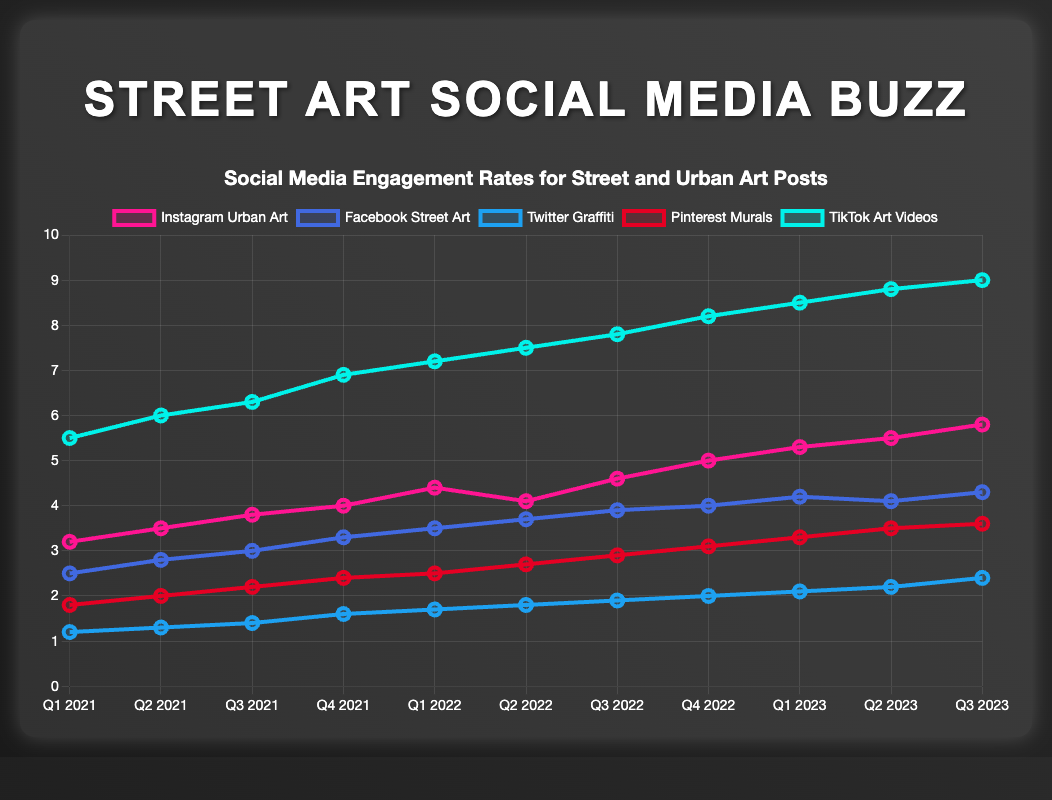Which platform shows the highest engagement rate in Q3 2023? The line chart shows the engagement rates for various platforms. TikTok Art Videos have the highest engagement rate in Q3 2023.
Answer: TikTok Art Videos How much did the engagement rate for Twitter Graffiti increase from Q1 2021 to Q3 2023? In Q1 2021, the engagement rate for Twitter Graffiti was 1.2. By Q3 2023, it increased to 2.4. The increase is 2.4 - 1.2 = 1.2.
Answer: 1.2 Which platform had a declining engagement rate in any quarter over the observed period? Referring to the line chart, Instagram Urban Art shows a decline from Q1 2022 to Q2 2022 going from 4.4 to 4.1.
Answer: Instagram Urban Art What was the average engagement rate for Pinterest Murals over the entire period? Sum the engagement rates for Pinterest Murals over all quarters and then divide by the number of data points:
(1.8 + 2.0 + 2.2 + 2.4 + 2.5 + 2.7 + 2.9 + 3.1 + 3.3 + 3.5 + 3.6) / 11 = 30.0 / 11 ≈ 2.73
Answer: 2.73 In which quarter did Facebook Street Art reach its peak engagement rate? The highest engagement rate for Facebook Street Art is observed at 4.3, which occurs in Q3 2023.
Answer: Q3 2023 What is the sum of engagement rates for Instagram Urban Art and TikTok Art Videos in Q1 2023? The engagement rates for Q1 2023 are: 
- Instagram Urban Art: 5.3 
- TikTok Art Videos: 8.5
Sum: 5.3 + 8.5 = 13.8
Answer: 13.8 